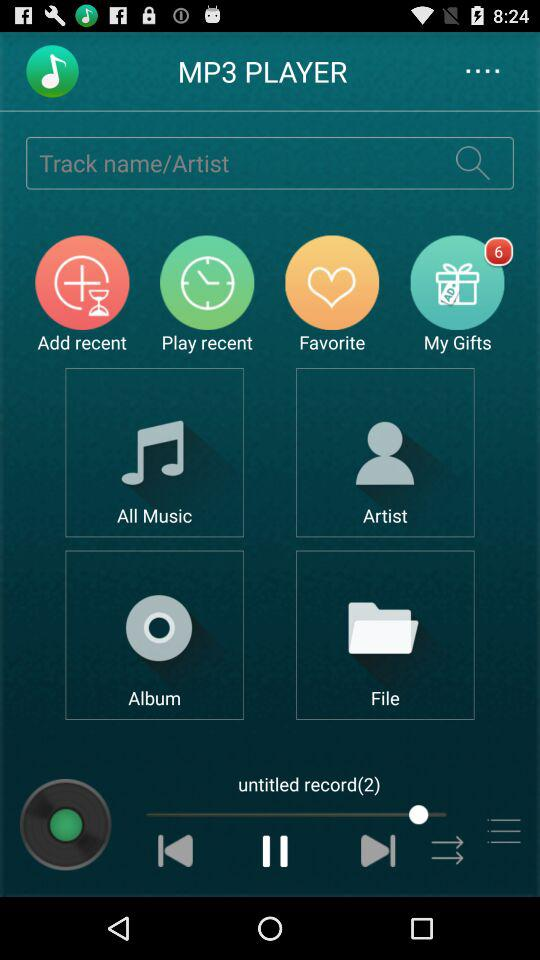Which audio is playing? The playing audio is "untitled record(2)". 